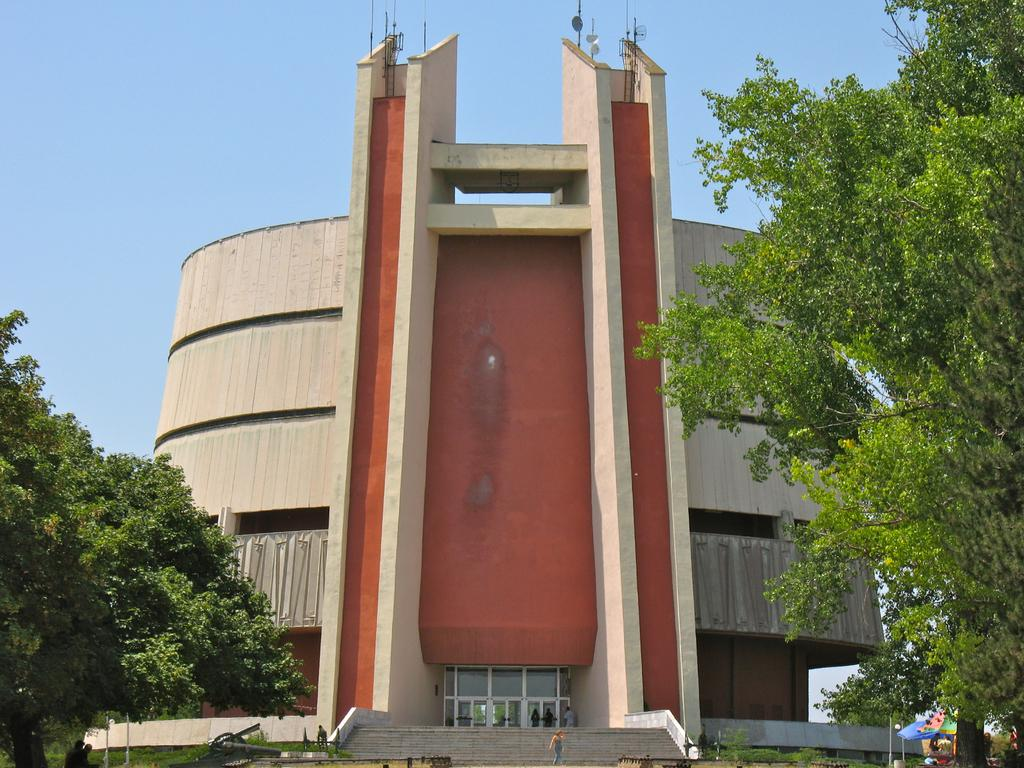What type of vegetation can be seen in the image? There are trees in the image. What is the color of the trees? The trees are green. Who or what else is present in the image? There are people in the image. What can be seen in the background of the image? There is a tent and a building in the background of the image. What is the color of the sky in the image? The sky is blue. What type of toys are being used by the people in the image? There is no mention of toys in the image; it features trees, people, a tent, a building, and a blue sky. What type of lettuce is being grown in the image? There is no lettuce present in the image; it features trees, people, a tent, a building, and a blue sky. 